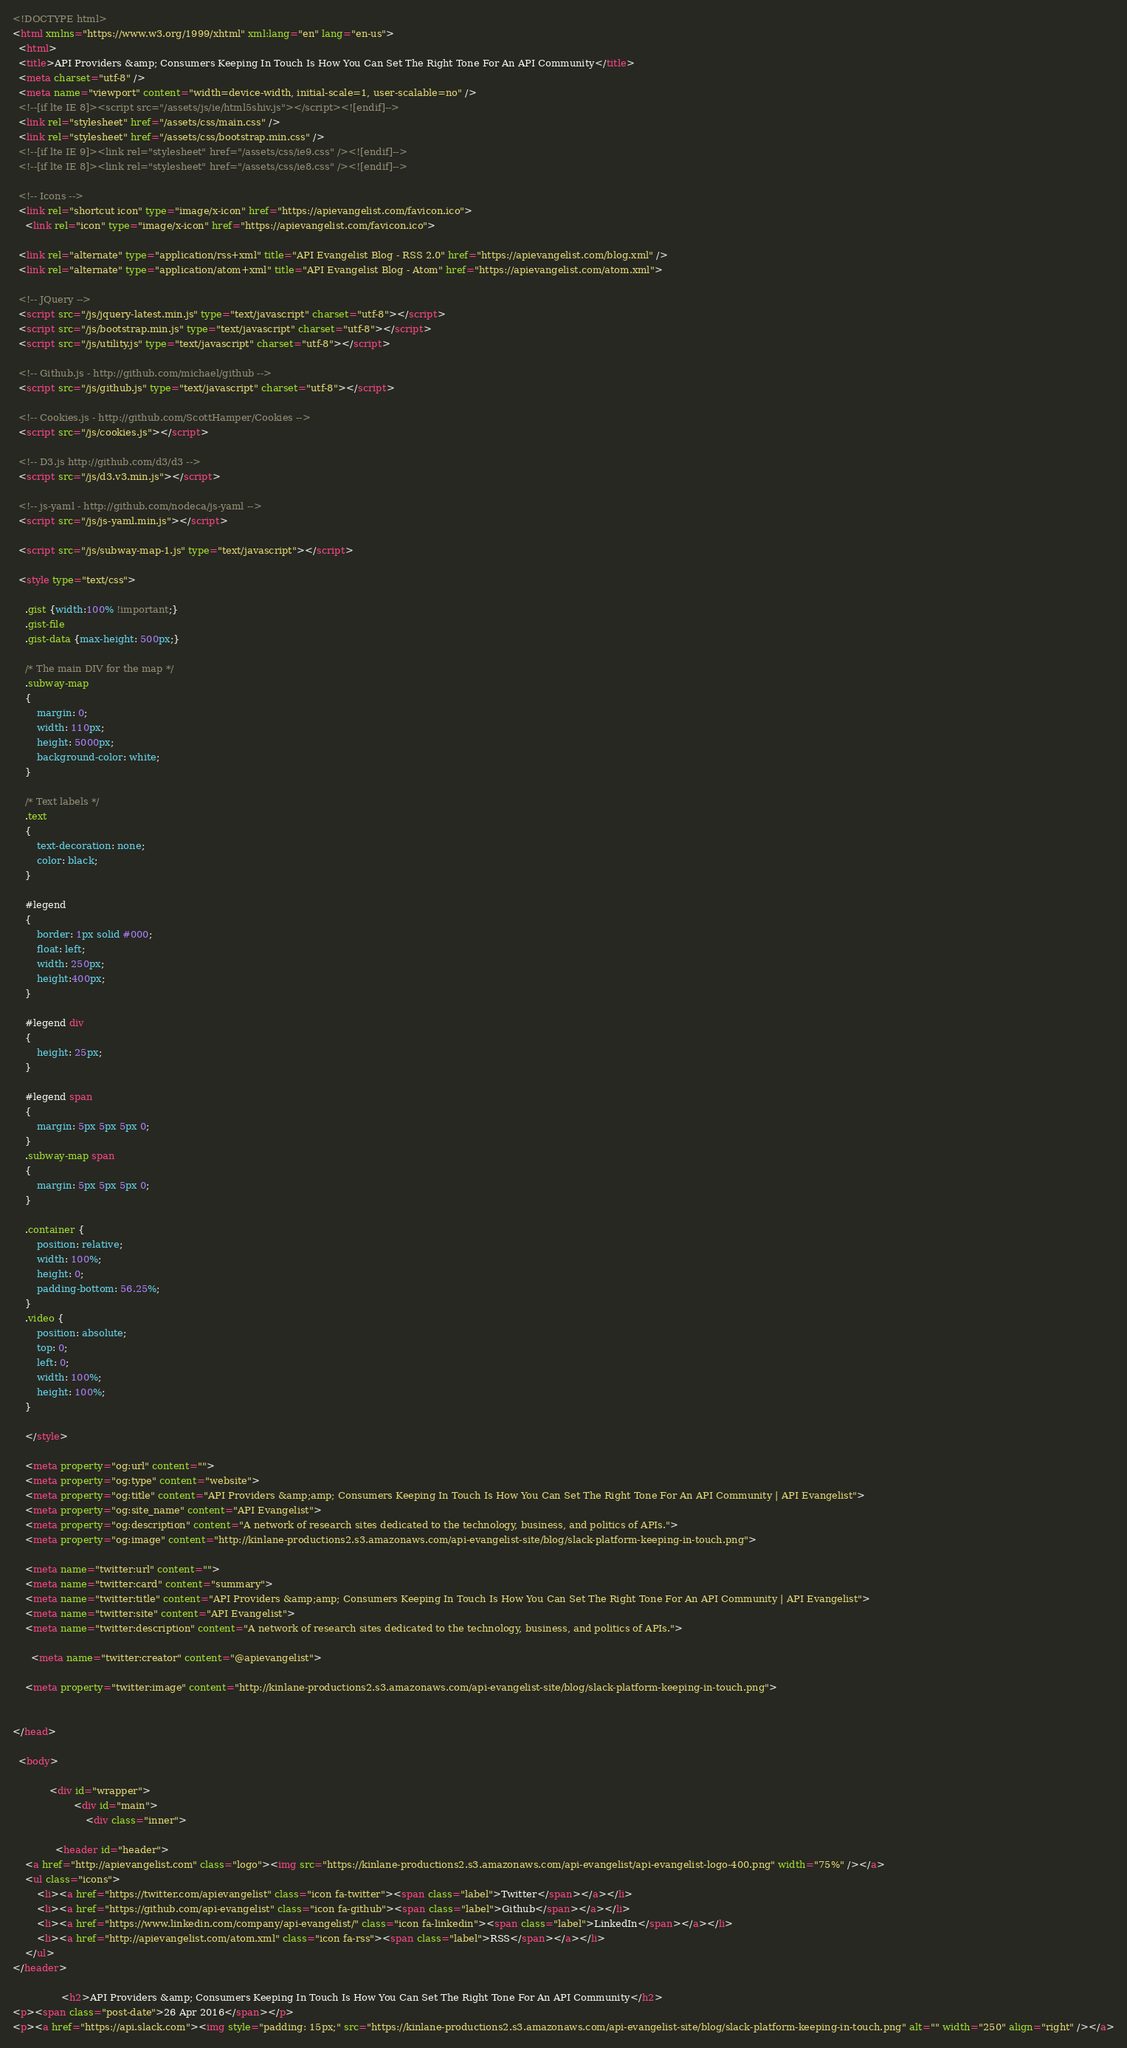Convert code to text. <code><loc_0><loc_0><loc_500><loc_500><_HTML_><!DOCTYPE html>
<html xmlns="https://www.w3.org/1999/xhtml" xml:lang="en" lang="en-us">
  <html>
  <title>API Providers &amp; Consumers Keeping In Touch Is How You Can Set The Right Tone For An API Community</title>
  <meta charset="utf-8" />
  <meta name="viewport" content="width=device-width, initial-scale=1, user-scalable=no" />
  <!--[if lte IE 8]><script src="/assets/js/ie/html5shiv.js"></script><![endif]-->
  <link rel="stylesheet" href="/assets/css/main.css" />
  <link rel="stylesheet" href="/assets/css/bootstrap.min.css" />
  <!--[if lte IE 9]><link rel="stylesheet" href="/assets/css/ie9.css" /><![endif]-->
  <!--[if lte IE 8]><link rel="stylesheet" href="/assets/css/ie8.css" /><![endif]-->

  <!-- Icons -->
  <link rel="shortcut icon" type="image/x-icon" href="https://apievangelist.com/favicon.ico">
	<link rel="icon" type="image/x-icon" href="https://apievangelist.com/favicon.ico">

  <link rel="alternate" type="application/rss+xml" title="API Evangelist Blog - RSS 2.0" href="https://apievangelist.com/blog.xml" />
  <link rel="alternate" type="application/atom+xml" title="API Evangelist Blog - Atom" href="https://apievangelist.com/atom.xml">

  <!-- JQuery -->
  <script src="/js/jquery-latest.min.js" type="text/javascript" charset="utf-8"></script>
  <script src="/js/bootstrap.min.js" type="text/javascript" charset="utf-8"></script>
  <script src="/js/utility.js" type="text/javascript" charset="utf-8"></script>

  <!-- Github.js - http://github.com/michael/github -->
  <script src="/js/github.js" type="text/javascript" charset="utf-8"></script>

  <!-- Cookies.js - http://github.com/ScottHamper/Cookies -->
  <script src="/js/cookies.js"></script>

  <!-- D3.js http://github.com/d3/d3 -->
  <script src="/js/d3.v3.min.js"></script>

  <!-- js-yaml - http://github.com/nodeca/js-yaml -->
  <script src="/js/js-yaml.min.js"></script>

  <script src="/js/subway-map-1.js" type="text/javascript"></script>

  <style type="text/css">

    .gist {width:100% !important;}
    .gist-file
    .gist-data {max-height: 500px;}

    /* The main DIV for the map */
    .subway-map
    {
        margin: 0;
        width: 110px;
        height: 5000px;
        background-color: white;
    }

    /* Text labels */
    .text
    {
        text-decoration: none;
        color: black;
    }

    #legend
    {
    	border: 1px solid #000;
        float: left;
        width: 250px;
        height:400px;
    }

    #legend div
    {
        height: 25px;
    }

    #legend span
    {
        margin: 5px 5px 5px 0;
    }
    .subway-map span
    {
        margin: 5px 5px 5px 0;
    }
    
    .container {
        position: relative;
        width: 100%;
        height: 0;
        padding-bottom: 56.25%;
    }
    .video {
        position: absolute;
        top: 0;
        left: 0;
        width: 100%;
        height: 100%;
    }    

    </style>

    <meta property="og:url" content="">
    <meta property="og:type" content="website">
    <meta property="og:title" content="API Providers &amp;amp; Consumers Keeping In Touch Is How You Can Set The Right Tone For An API Community | API Evangelist">
    <meta property="og:site_name" content="API Evangelist">
    <meta property="og:description" content="A network of research sites dedicated to the technology, business, and politics of APIs.">
    <meta property="og:image" content="http://kinlane-productions2.s3.amazonaws.com/api-evangelist-site/blog/slack-platform-keeping-in-touch.png">

    <meta name="twitter:url" content="">
    <meta name="twitter:card" content="summary">
    <meta name="twitter:title" content="API Providers &amp;amp; Consumers Keeping In Touch Is How You Can Set The Right Tone For An API Community | API Evangelist">
    <meta name="twitter:site" content="API Evangelist">
    <meta name="twitter:description" content="A network of research sites dedicated to the technology, business, and politics of APIs.">
    
      <meta name="twitter:creator" content="@apievangelist">
    
    <meta property="twitter:image" content="http://kinlane-productions2.s3.amazonaws.com/api-evangelist-site/blog/slack-platform-keeping-in-touch.png">


</head>

  <body>

			<div id="wrapper">
					<div id="main">
						<div class="inner">

              <header id="header">
	<a href="http://apievangelist.com" class="logo"><img src="https://kinlane-productions2.s3.amazonaws.com/api-evangelist/api-evangelist-logo-400.png" width="75%" /></a>
	<ul class="icons">
		<li><a href="https://twitter.com/apievangelist" class="icon fa-twitter"><span class="label">Twitter</span></a></li>
		<li><a href="https://github.com/api-evangelist" class="icon fa-github"><span class="label">Github</span></a></li>
		<li><a href="https://www.linkedin.com/company/api-evangelist/" class="icon fa-linkedin"><span class="label">LinkedIn</span></a></li>
		<li><a href="http://apievangelist.com/atom.xml" class="icon fa-rss"><span class="label">RSS</span></a></li>
	</ul>
</header>

    	        <h2>API Providers &amp; Consumers Keeping In Touch Is How You Can Set The Right Tone For An API Community</h2>
<p><span class="post-date">26 Apr 2016</span></p>
<p><a href="https://api.slack.com"><img style="padding: 15px;" src="https://kinlane-productions2.s3.amazonaws.com/api-evangelist-site/blog/slack-platform-keeping-in-touch.png" alt="" width="250" align="right" /></a></code> 